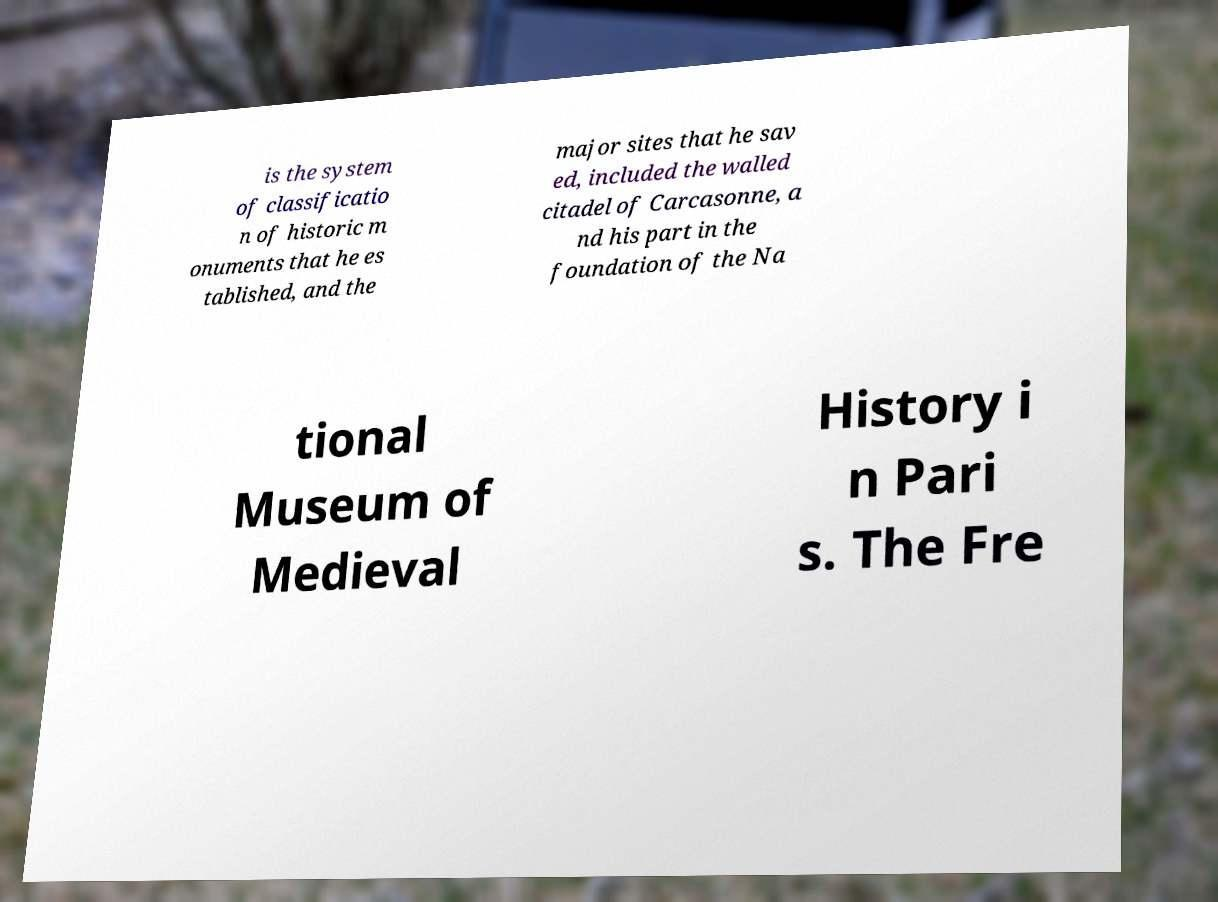What messages or text are displayed in this image? I need them in a readable, typed format. is the system of classificatio n of historic m onuments that he es tablished, and the major sites that he sav ed, included the walled citadel of Carcasonne, a nd his part in the foundation of the Na tional Museum of Medieval History i n Pari s. The Fre 